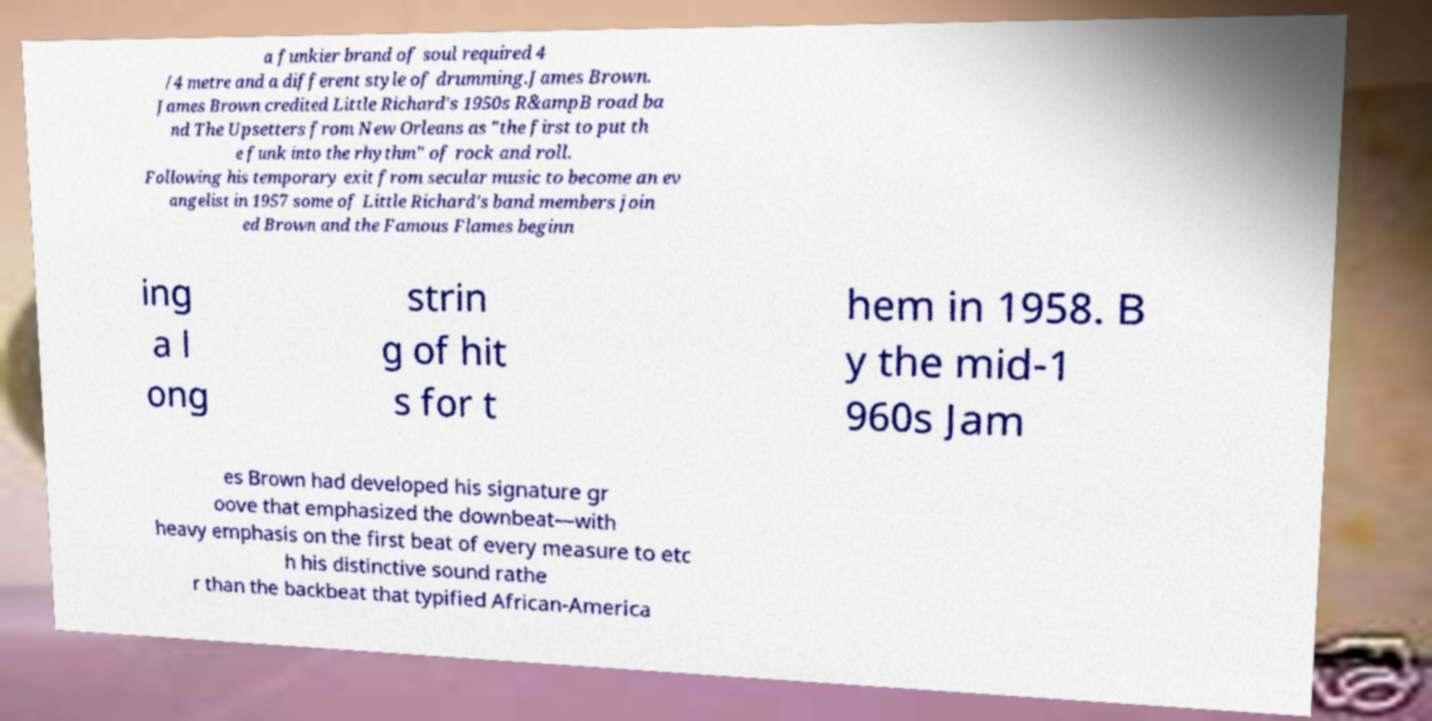Could you assist in decoding the text presented in this image and type it out clearly? a funkier brand of soul required 4 /4 metre and a different style of drumming.James Brown. James Brown credited Little Richard's 1950s R&ampB road ba nd The Upsetters from New Orleans as "the first to put th e funk into the rhythm" of rock and roll. Following his temporary exit from secular music to become an ev angelist in 1957 some of Little Richard's band members join ed Brown and the Famous Flames beginn ing a l ong strin g of hit s for t hem in 1958. B y the mid-1 960s Jam es Brown had developed his signature gr oove that emphasized the downbeat—with heavy emphasis on the first beat of every measure to etc h his distinctive sound rathe r than the backbeat that typified African-America 